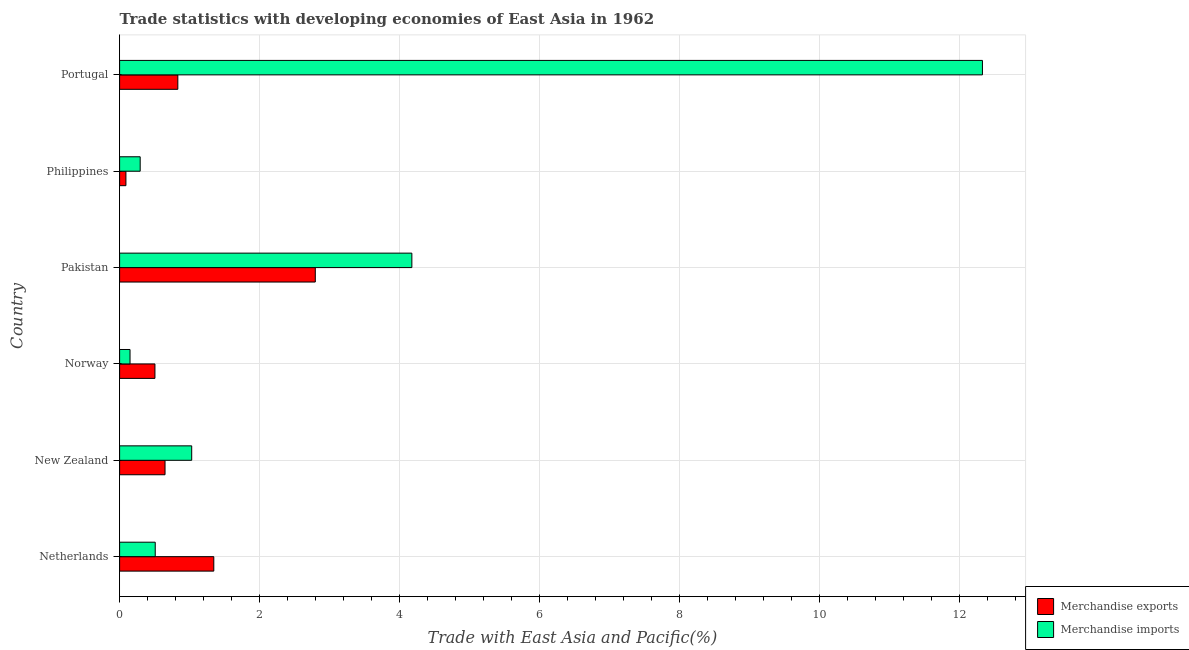Are the number of bars on each tick of the Y-axis equal?
Offer a very short reply. Yes. What is the label of the 2nd group of bars from the top?
Provide a succinct answer. Philippines. In how many cases, is the number of bars for a given country not equal to the number of legend labels?
Keep it short and to the point. 0. What is the merchandise exports in Philippines?
Give a very brief answer. 0.09. Across all countries, what is the maximum merchandise exports?
Ensure brevity in your answer.  2.8. Across all countries, what is the minimum merchandise exports?
Provide a short and direct response. 0.09. In which country was the merchandise exports maximum?
Ensure brevity in your answer.  Pakistan. In which country was the merchandise imports minimum?
Offer a terse response. Norway. What is the total merchandise imports in the graph?
Ensure brevity in your answer.  18.48. What is the difference between the merchandise exports in Netherlands and that in Portugal?
Give a very brief answer. 0.51. What is the difference between the merchandise exports in Philippines and the merchandise imports in New Zealand?
Offer a very short reply. -0.94. What is the average merchandise exports per country?
Ensure brevity in your answer.  1.04. What is the difference between the merchandise exports and merchandise imports in Philippines?
Your response must be concise. -0.2. In how many countries, is the merchandise imports greater than 6.8 %?
Offer a very short reply. 1. What is the ratio of the merchandise imports in New Zealand to that in Portugal?
Ensure brevity in your answer.  0.08. Is the merchandise exports in Netherlands less than that in Portugal?
Your answer should be compact. No. Is the difference between the merchandise exports in Netherlands and Norway greater than the difference between the merchandise imports in Netherlands and Norway?
Offer a terse response. Yes. What is the difference between the highest and the second highest merchandise imports?
Your response must be concise. 8.15. What is the difference between the highest and the lowest merchandise exports?
Your answer should be very brief. 2.71. How many countries are there in the graph?
Offer a terse response. 6. What is the title of the graph?
Your answer should be compact. Trade statistics with developing economies of East Asia in 1962. What is the label or title of the X-axis?
Your answer should be compact. Trade with East Asia and Pacific(%). What is the label or title of the Y-axis?
Provide a short and direct response. Country. What is the Trade with East Asia and Pacific(%) in Merchandise exports in Netherlands?
Give a very brief answer. 1.35. What is the Trade with East Asia and Pacific(%) in Merchandise imports in Netherlands?
Ensure brevity in your answer.  0.51. What is the Trade with East Asia and Pacific(%) of Merchandise exports in New Zealand?
Your answer should be very brief. 0.65. What is the Trade with East Asia and Pacific(%) in Merchandise imports in New Zealand?
Ensure brevity in your answer.  1.03. What is the Trade with East Asia and Pacific(%) of Merchandise exports in Norway?
Make the answer very short. 0.5. What is the Trade with East Asia and Pacific(%) in Merchandise imports in Norway?
Your response must be concise. 0.15. What is the Trade with East Asia and Pacific(%) in Merchandise exports in Pakistan?
Offer a terse response. 2.8. What is the Trade with East Asia and Pacific(%) in Merchandise imports in Pakistan?
Offer a terse response. 4.18. What is the Trade with East Asia and Pacific(%) of Merchandise exports in Philippines?
Your answer should be very brief. 0.09. What is the Trade with East Asia and Pacific(%) of Merchandise imports in Philippines?
Keep it short and to the point. 0.29. What is the Trade with East Asia and Pacific(%) of Merchandise exports in Portugal?
Make the answer very short. 0.83. What is the Trade with East Asia and Pacific(%) in Merchandise imports in Portugal?
Make the answer very short. 12.33. Across all countries, what is the maximum Trade with East Asia and Pacific(%) of Merchandise exports?
Your answer should be compact. 2.8. Across all countries, what is the maximum Trade with East Asia and Pacific(%) of Merchandise imports?
Provide a succinct answer. 12.33. Across all countries, what is the minimum Trade with East Asia and Pacific(%) of Merchandise exports?
Your answer should be very brief. 0.09. Across all countries, what is the minimum Trade with East Asia and Pacific(%) of Merchandise imports?
Make the answer very short. 0.15. What is the total Trade with East Asia and Pacific(%) of Merchandise exports in the graph?
Your response must be concise. 6.22. What is the total Trade with East Asia and Pacific(%) of Merchandise imports in the graph?
Offer a terse response. 18.48. What is the difference between the Trade with East Asia and Pacific(%) in Merchandise exports in Netherlands and that in New Zealand?
Offer a very short reply. 0.7. What is the difference between the Trade with East Asia and Pacific(%) of Merchandise imports in Netherlands and that in New Zealand?
Make the answer very short. -0.52. What is the difference between the Trade with East Asia and Pacific(%) in Merchandise exports in Netherlands and that in Norway?
Offer a terse response. 0.84. What is the difference between the Trade with East Asia and Pacific(%) in Merchandise imports in Netherlands and that in Norway?
Offer a very short reply. 0.36. What is the difference between the Trade with East Asia and Pacific(%) of Merchandise exports in Netherlands and that in Pakistan?
Your answer should be very brief. -1.45. What is the difference between the Trade with East Asia and Pacific(%) in Merchandise imports in Netherlands and that in Pakistan?
Provide a succinct answer. -3.67. What is the difference between the Trade with East Asia and Pacific(%) in Merchandise exports in Netherlands and that in Philippines?
Offer a terse response. 1.26. What is the difference between the Trade with East Asia and Pacific(%) in Merchandise imports in Netherlands and that in Philippines?
Make the answer very short. 0.22. What is the difference between the Trade with East Asia and Pacific(%) in Merchandise exports in Netherlands and that in Portugal?
Ensure brevity in your answer.  0.51. What is the difference between the Trade with East Asia and Pacific(%) in Merchandise imports in Netherlands and that in Portugal?
Give a very brief answer. -11.82. What is the difference between the Trade with East Asia and Pacific(%) in Merchandise exports in New Zealand and that in Norway?
Offer a terse response. 0.14. What is the difference between the Trade with East Asia and Pacific(%) in Merchandise imports in New Zealand and that in Norway?
Your answer should be very brief. 0.88. What is the difference between the Trade with East Asia and Pacific(%) of Merchandise exports in New Zealand and that in Pakistan?
Provide a succinct answer. -2.15. What is the difference between the Trade with East Asia and Pacific(%) in Merchandise imports in New Zealand and that in Pakistan?
Provide a short and direct response. -3.15. What is the difference between the Trade with East Asia and Pacific(%) in Merchandise exports in New Zealand and that in Philippines?
Offer a terse response. 0.56. What is the difference between the Trade with East Asia and Pacific(%) in Merchandise imports in New Zealand and that in Philippines?
Give a very brief answer. 0.74. What is the difference between the Trade with East Asia and Pacific(%) of Merchandise exports in New Zealand and that in Portugal?
Ensure brevity in your answer.  -0.18. What is the difference between the Trade with East Asia and Pacific(%) in Merchandise imports in New Zealand and that in Portugal?
Provide a succinct answer. -11.3. What is the difference between the Trade with East Asia and Pacific(%) in Merchandise exports in Norway and that in Pakistan?
Your response must be concise. -2.29. What is the difference between the Trade with East Asia and Pacific(%) of Merchandise imports in Norway and that in Pakistan?
Give a very brief answer. -4.03. What is the difference between the Trade with East Asia and Pacific(%) of Merchandise exports in Norway and that in Philippines?
Your answer should be very brief. 0.41. What is the difference between the Trade with East Asia and Pacific(%) in Merchandise imports in Norway and that in Philippines?
Provide a succinct answer. -0.14. What is the difference between the Trade with East Asia and Pacific(%) in Merchandise exports in Norway and that in Portugal?
Your response must be concise. -0.33. What is the difference between the Trade with East Asia and Pacific(%) of Merchandise imports in Norway and that in Portugal?
Your response must be concise. -12.18. What is the difference between the Trade with East Asia and Pacific(%) in Merchandise exports in Pakistan and that in Philippines?
Give a very brief answer. 2.71. What is the difference between the Trade with East Asia and Pacific(%) in Merchandise imports in Pakistan and that in Philippines?
Your answer should be compact. 3.88. What is the difference between the Trade with East Asia and Pacific(%) of Merchandise exports in Pakistan and that in Portugal?
Make the answer very short. 1.96. What is the difference between the Trade with East Asia and Pacific(%) in Merchandise imports in Pakistan and that in Portugal?
Give a very brief answer. -8.15. What is the difference between the Trade with East Asia and Pacific(%) of Merchandise exports in Philippines and that in Portugal?
Ensure brevity in your answer.  -0.74. What is the difference between the Trade with East Asia and Pacific(%) of Merchandise imports in Philippines and that in Portugal?
Offer a very short reply. -12.03. What is the difference between the Trade with East Asia and Pacific(%) in Merchandise exports in Netherlands and the Trade with East Asia and Pacific(%) in Merchandise imports in New Zealand?
Your answer should be compact. 0.32. What is the difference between the Trade with East Asia and Pacific(%) in Merchandise exports in Netherlands and the Trade with East Asia and Pacific(%) in Merchandise imports in Norway?
Your response must be concise. 1.2. What is the difference between the Trade with East Asia and Pacific(%) in Merchandise exports in Netherlands and the Trade with East Asia and Pacific(%) in Merchandise imports in Pakistan?
Provide a short and direct response. -2.83. What is the difference between the Trade with East Asia and Pacific(%) in Merchandise exports in Netherlands and the Trade with East Asia and Pacific(%) in Merchandise imports in Philippines?
Provide a short and direct response. 1.05. What is the difference between the Trade with East Asia and Pacific(%) of Merchandise exports in Netherlands and the Trade with East Asia and Pacific(%) of Merchandise imports in Portugal?
Provide a succinct answer. -10.98. What is the difference between the Trade with East Asia and Pacific(%) of Merchandise exports in New Zealand and the Trade with East Asia and Pacific(%) of Merchandise imports in Norway?
Give a very brief answer. 0.5. What is the difference between the Trade with East Asia and Pacific(%) in Merchandise exports in New Zealand and the Trade with East Asia and Pacific(%) in Merchandise imports in Pakistan?
Ensure brevity in your answer.  -3.53. What is the difference between the Trade with East Asia and Pacific(%) of Merchandise exports in New Zealand and the Trade with East Asia and Pacific(%) of Merchandise imports in Philippines?
Your answer should be very brief. 0.35. What is the difference between the Trade with East Asia and Pacific(%) of Merchandise exports in New Zealand and the Trade with East Asia and Pacific(%) of Merchandise imports in Portugal?
Give a very brief answer. -11.68. What is the difference between the Trade with East Asia and Pacific(%) of Merchandise exports in Norway and the Trade with East Asia and Pacific(%) of Merchandise imports in Pakistan?
Provide a succinct answer. -3.67. What is the difference between the Trade with East Asia and Pacific(%) in Merchandise exports in Norway and the Trade with East Asia and Pacific(%) in Merchandise imports in Philippines?
Your answer should be very brief. 0.21. What is the difference between the Trade with East Asia and Pacific(%) in Merchandise exports in Norway and the Trade with East Asia and Pacific(%) in Merchandise imports in Portugal?
Offer a terse response. -11.82. What is the difference between the Trade with East Asia and Pacific(%) of Merchandise exports in Pakistan and the Trade with East Asia and Pacific(%) of Merchandise imports in Philippines?
Make the answer very short. 2.5. What is the difference between the Trade with East Asia and Pacific(%) of Merchandise exports in Pakistan and the Trade with East Asia and Pacific(%) of Merchandise imports in Portugal?
Your response must be concise. -9.53. What is the difference between the Trade with East Asia and Pacific(%) in Merchandise exports in Philippines and the Trade with East Asia and Pacific(%) in Merchandise imports in Portugal?
Provide a short and direct response. -12.24. What is the average Trade with East Asia and Pacific(%) in Merchandise exports per country?
Keep it short and to the point. 1.04. What is the average Trade with East Asia and Pacific(%) in Merchandise imports per country?
Offer a very short reply. 3.08. What is the difference between the Trade with East Asia and Pacific(%) in Merchandise exports and Trade with East Asia and Pacific(%) in Merchandise imports in Netherlands?
Make the answer very short. 0.84. What is the difference between the Trade with East Asia and Pacific(%) of Merchandise exports and Trade with East Asia and Pacific(%) of Merchandise imports in New Zealand?
Your response must be concise. -0.38. What is the difference between the Trade with East Asia and Pacific(%) in Merchandise exports and Trade with East Asia and Pacific(%) in Merchandise imports in Norway?
Ensure brevity in your answer.  0.36. What is the difference between the Trade with East Asia and Pacific(%) in Merchandise exports and Trade with East Asia and Pacific(%) in Merchandise imports in Pakistan?
Ensure brevity in your answer.  -1.38. What is the difference between the Trade with East Asia and Pacific(%) of Merchandise exports and Trade with East Asia and Pacific(%) of Merchandise imports in Philippines?
Make the answer very short. -0.2. What is the difference between the Trade with East Asia and Pacific(%) in Merchandise exports and Trade with East Asia and Pacific(%) in Merchandise imports in Portugal?
Offer a terse response. -11.49. What is the ratio of the Trade with East Asia and Pacific(%) of Merchandise exports in Netherlands to that in New Zealand?
Give a very brief answer. 2.07. What is the ratio of the Trade with East Asia and Pacific(%) in Merchandise imports in Netherlands to that in New Zealand?
Your response must be concise. 0.49. What is the ratio of the Trade with East Asia and Pacific(%) of Merchandise exports in Netherlands to that in Norway?
Offer a very short reply. 2.67. What is the ratio of the Trade with East Asia and Pacific(%) in Merchandise imports in Netherlands to that in Norway?
Offer a very short reply. 3.41. What is the ratio of the Trade with East Asia and Pacific(%) of Merchandise exports in Netherlands to that in Pakistan?
Provide a short and direct response. 0.48. What is the ratio of the Trade with East Asia and Pacific(%) of Merchandise imports in Netherlands to that in Pakistan?
Offer a terse response. 0.12. What is the ratio of the Trade with East Asia and Pacific(%) in Merchandise exports in Netherlands to that in Philippines?
Provide a succinct answer. 14.89. What is the ratio of the Trade with East Asia and Pacific(%) of Merchandise imports in Netherlands to that in Philippines?
Offer a terse response. 1.73. What is the ratio of the Trade with East Asia and Pacific(%) in Merchandise exports in Netherlands to that in Portugal?
Provide a short and direct response. 1.62. What is the ratio of the Trade with East Asia and Pacific(%) of Merchandise imports in Netherlands to that in Portugal?
Your answer should be compact. 0.04. What is the ratio of the Trade with East Asia and Pacific(%) in Merchandise exports in New Zealand to that in Norway?
Ensure brevity in your answer.  1.29. What is the ratio of the Trade with East Asia and Pacific(%) in Merchandise imports in New Zealand to that in Norway?
Offer a very short reply. 6.91. What is the ratio of the Trade with East Asia and Pacific(%) of Merchandise exports in New Zealand to that in Pakistan?
Keep it short and to the point. 0.23. What is the ratio of the Trade with East Asia and Pacific(%) of Merchandise imports in New Zealand to that in Pakistan?
Provide a succinct answer. 0.25. What is the ratio of the Trade with East Asia and Pacific(%) in Merchandise exports in New Zealand to that in Philippines?
Make the answer very short. 7.18. What is the ratio of the Trade with East Asia and Pacific(%) of Merchandise imports in New Zealand to that in Philippines?
Your response must be concise. 3.5. What is the ratio of the Trade with East Asia and Pacific(%) of Merchandise exports in New Zealand to that in Portugal?
Your answer should be very brief. 0.78. What is the ratio of the Trade with East Asia and Pacific(%) of Merchandise imports in New Zealand to that in Portugal?
Make the answer very short. 0.08. What is the ratio of the Trade with East Asia and Pacific(%) of Merchandise exports in Norway to that in Pakistan?
Keep it short and to the point. 0.18. What is the ratio of the Trade with East Asia and Pacific(%) in Merchandise imports in Norway to that in Pakistan?
Give a very brief answer. 0.04. What is the ratio of the Trade with East Asia and Pacific(%) in Merchandise exports in Norway to that in Philippines?
Your answer should be compact. 5.59. What is the ratio of the Trade with East Asia and Pacific(%) of Merchandise imports in Norway to that in Philippines?
Your response must be concise. 0.51. What is the ratio of the Trade with East Asia and Pacific(%) of Merchandise exports in Norway to that in Portugal?
Offer a terse response. 0.61. What is the ratio of the Trade with East Asia and Pacific(%) in Merchandise imports in Norway to that in Portugal?
Provide a short and direct response. 0.01. What is the ratio of the Trade with East Asia and Pacific(%) in Merchandise exports in Pakistan to that in Philippines?
Your answer should be compact. 30.93. What is the ratio of the Trade with East Asia and Pacific(%) of Merchandise imports in Pakistan to that in Philippines?
Offer a terse response. 14.2. What is the ratio of the Trade with East Asia and Pacific(%) in Merchandise exports in Pakistan to that in Portugal?
Your answer should be very brief. 3.36. What is the ratio of the Trade with East Asia and Pacific(%) in Merchandise imports in Pakistan to that in Portugal?
Make the answer very short. 0.34. What is the ratio of the Trade with East Asia and Pacific(%) in Merchandise exports in Philippines to that in Portugal?
Offer a very short reply. 0.11. What is the ratio of the Trade with East Asia and Pacific(%) in Merchandise imports in Philippines to that in Portugal?
Your answer should be compact. 0.02. What is the difference between the highest and the second highest Trade with East Asia and Pacific(%) of Merchandise exports?
Offer a terse response. 1.45. What is the difference between the highest and the second highest Trade with East Asia and Pacific(%) of Merchandise imports?
Keep it short and to the point. 8.15. What is the difference between the highest and the lowest Trade with East Asia and Pacific(%) in Merchandise exports?
Provide a short and direct response. 2.71. What is the difference between the highest and the lowest Trade with East Asia and Pacific(%) of Merchandise imports?
Your response must be concise. 12.18. 